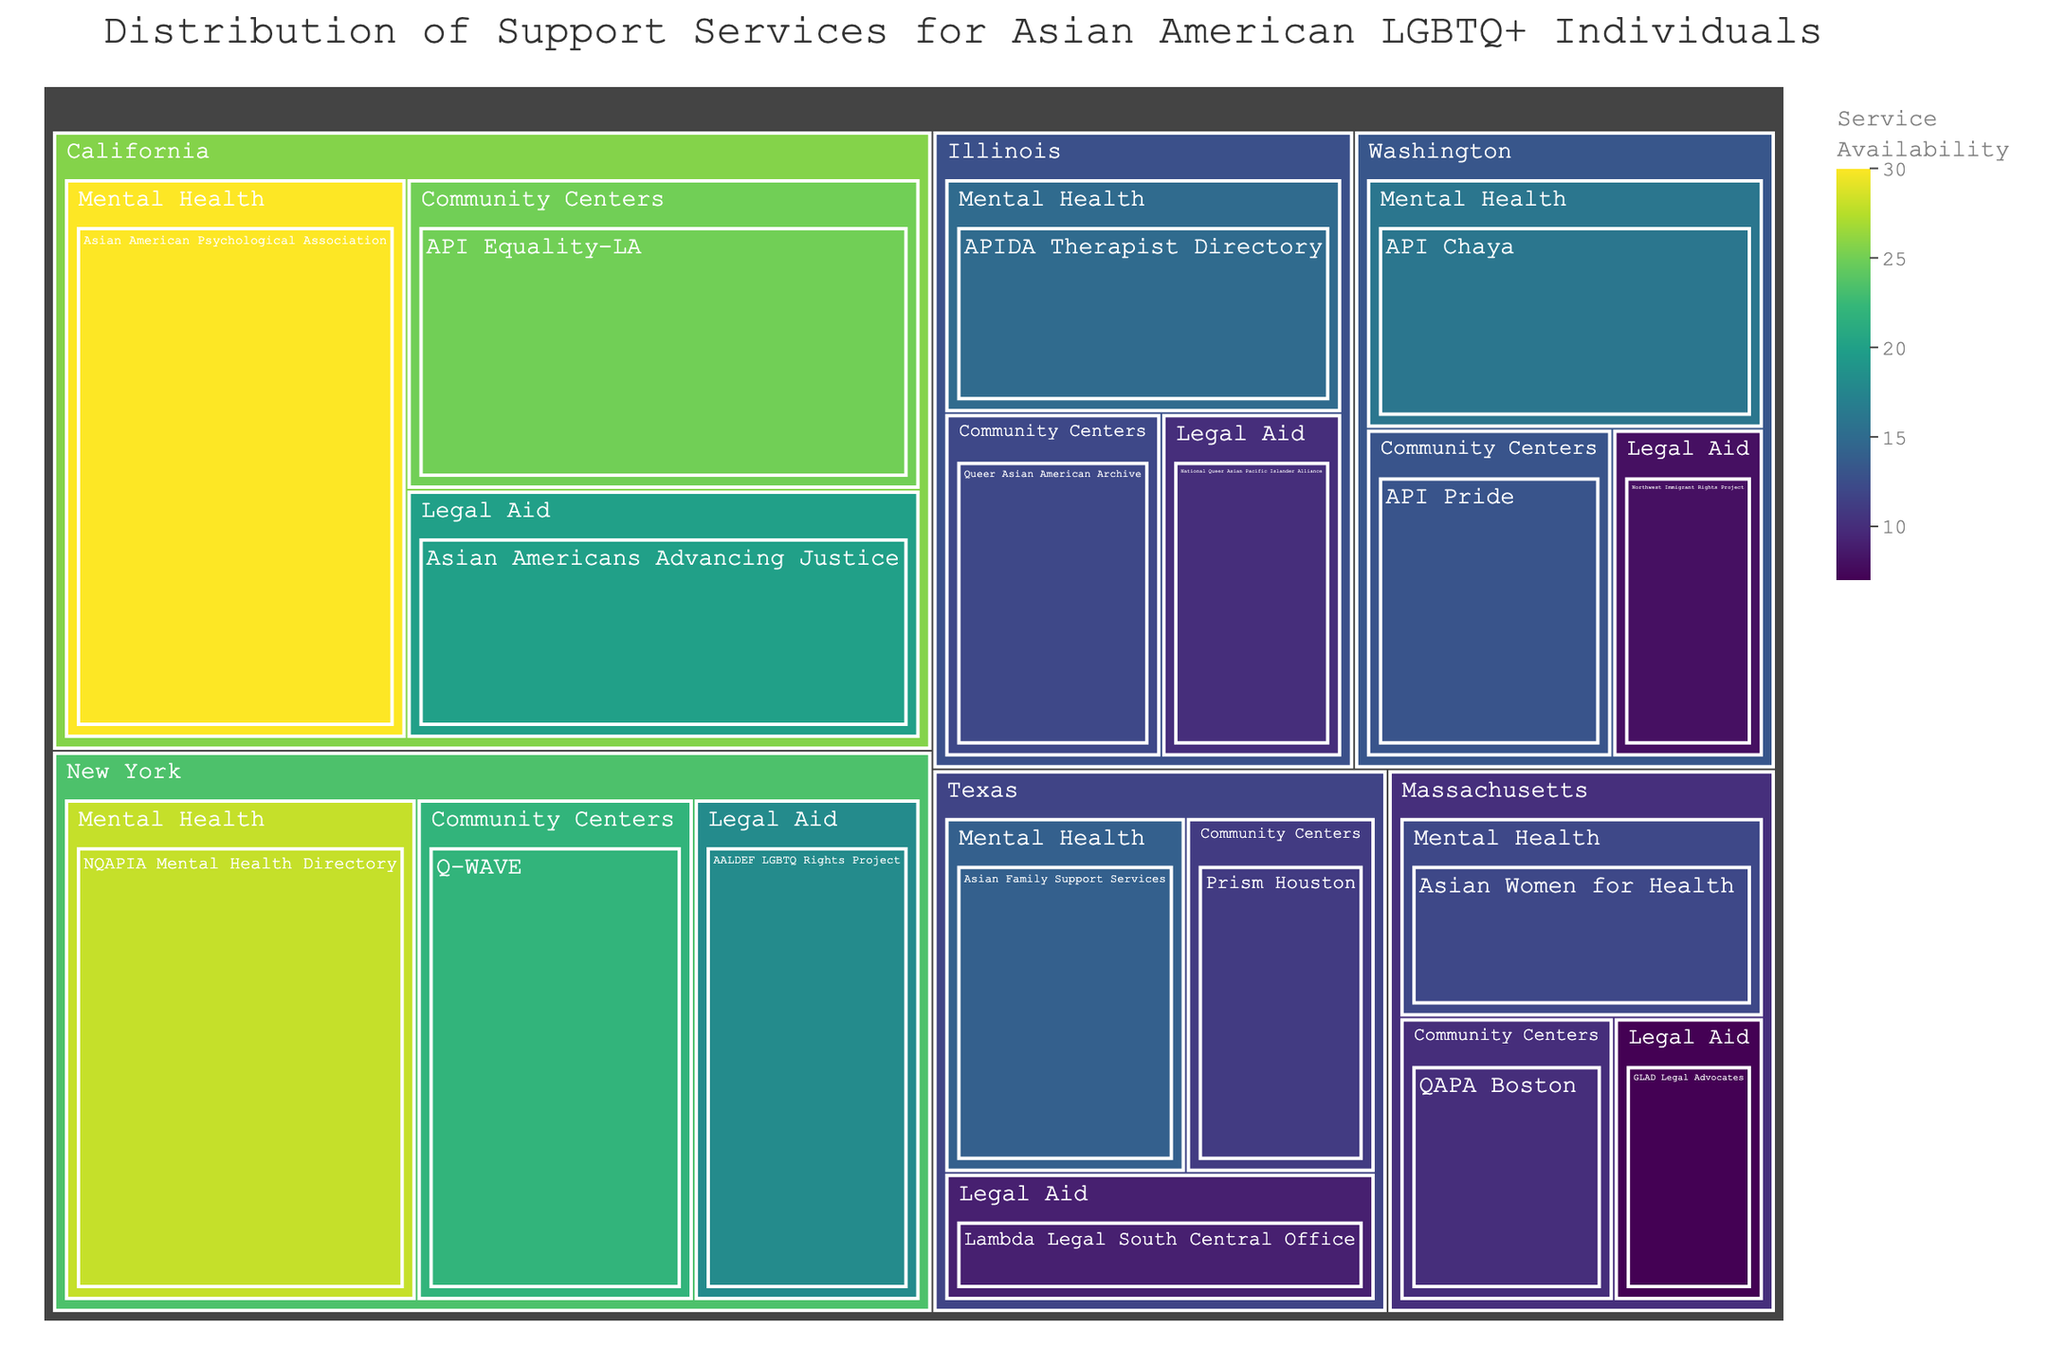How many support services are available in California? To find the number of support services available in California, look at the treemap section for California and count the number of services listed under it. There are three categories: Mental Health, Community Centers, and Legal Aid. Each has one service listed.
Answer: 3 Which state has the most support services available? By comparing the number of support services available in each state's section of the treemap, California has the most with 3 services.
Answer: California What is the total value of Legal Aid support services in New York? To calculate the total value, find the Legal Aid section under New York and sum the values of the services listed. The value for the AALDEF LGBTQ Rights Project is 18.
Answer: 18 Which category has the highest service availability overall? By examining each category across all states and summing their values, the Mental Health category has the highest service availability with values as follows: 30 (CA) + 28 (NY) + 15 (IL) + 14 (TX) + 16 (WA) + 12 (MA) = 115.
Answer: Mental Health How does the availability of Mental Health services in Texas compare to those in Illinois? Compare the values for Mental Health in Texas and Illinois. Texas has 14, while Illinois has 15.
Answer: Illinois has more Which service has the highest availability in California? Looking at the services listed under California, the Asian American Psychological Association in the Mental Health category has the highest value of 30.
Answer: Asian American Psychological Association What is the combined value of Community Center services in Washington and Massachusetts? Find the Community Center values in Washington and Massachusetts and sum them up: 13 (API Pride in WA) + 10 (QAPA Boston in MA) = 23.
Answer: 23 What is the difference in service availability between the Asian Americans Advancing Justice (CA) and Lambda Legal South Central Office (TX)? Subtract the value of Lambda Legal South Central Office from Asian Americans Advancing Justice: 20 (CA Legal Aid) - 9 (TX Legal Aid) = 11.
Answer: 11 Which state has the least representation in the treemap? By examining the number of services listed under each state, states such as Texas, Washington, and Massachusetts each have 3 services, none has fewer than 3. Therefore, they all have equal representation and the least.
Answer: Texas, Washington, Massachusetts What's the overall distribution of Mental Health services across all states? To determine this, sum the values of all Mental Health services listed: 30 (CA) + 28 (NY) + 15 (IL) + 14 (TX) + 16 (WA) + 12 (MA) = 115.
Answer: 115 